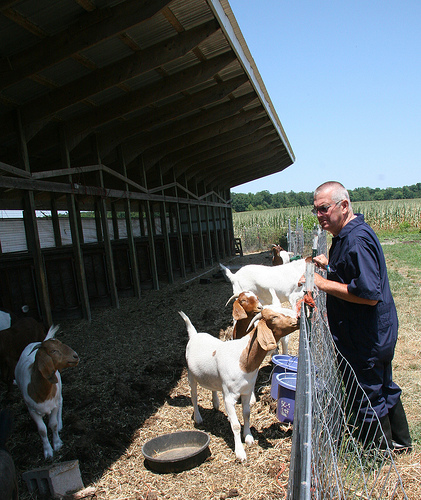<image>
Is the man in front of the goat? Yes. The man is positioned in front of the goat, appearing closer to the camera viewpoint. 